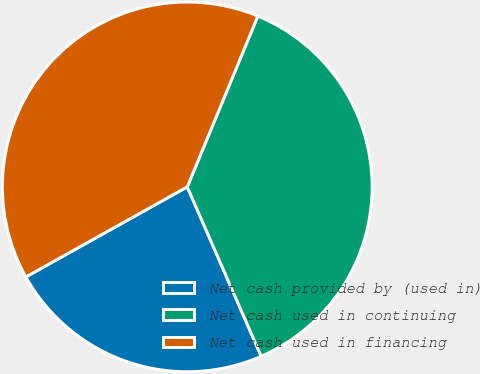<chart> <loc_0><loc_0><loc_500><loc_500><pie_chart><fcel>Net cash provided by (used in)<fcel>Net cash used in continuing<fcel>Net cash used in financing<nl><fcel>23.45%<fcel>37.21%<fcel>39.34%<nl></chart> 